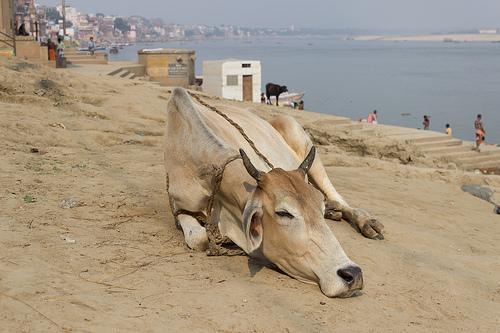How many cows are lying down?
Give a very brief answer. 1. How many black cows are there?
Give a very brief answer. 1. 